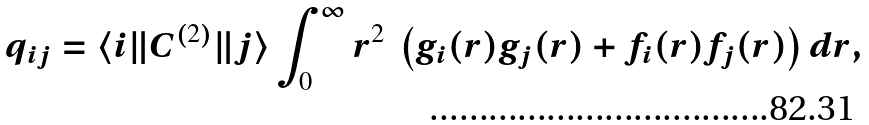Convert formula to latex. <formula><loc_0><loc_0><loc_500><loc_500>q _ { i j } = \langle i \| C ^ { ( 2 ) } \| j \rangle \int ^ { \infty } _ { 0 } r ^ { 2 } \ \left ( g _ { i } ( r ) g _ { j } ( r ) + f _ { i } ( r ) f _ { j } ( r ) \right ) d r ,</formula> 